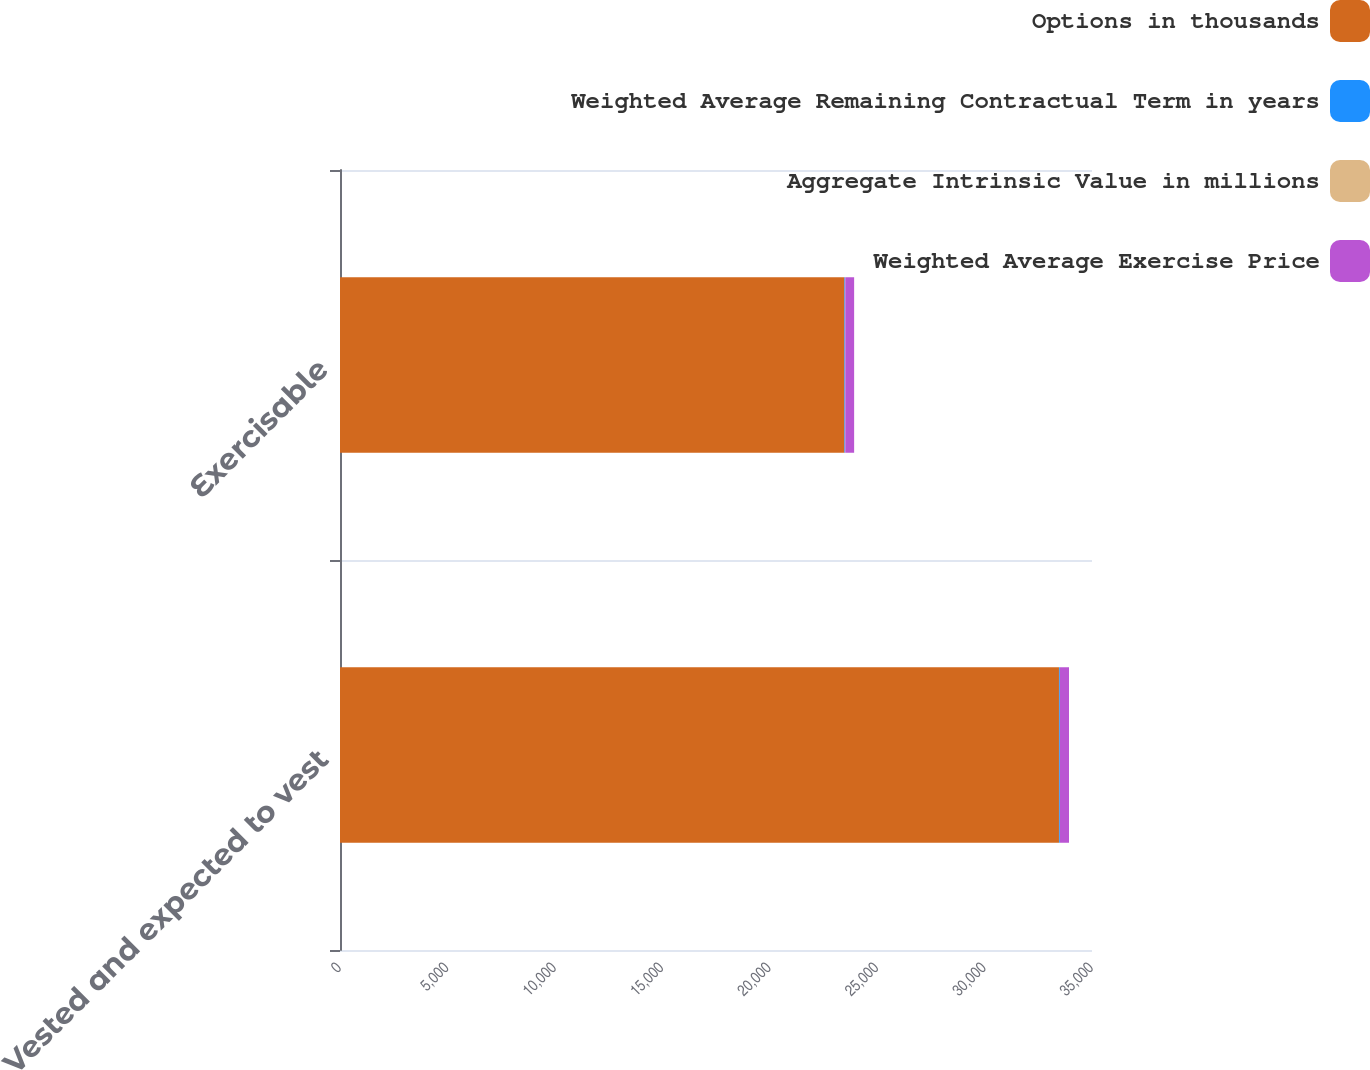Convert chart. <chart><loc_0><loc_0><loc_500><loc_500><stacked_bar_chart><ecel><fcel>Vested and expected to vest<fcel>Exercisable<nl><fcel>Options in thousands<fcel>33463<fcel>23479<nl><fcel>Weighted Average Remaining Contractual Term in years<fcel>39.82<fcel>33.99<nl><fcel>Aggregate Intrinsic Value in millions<fcel>6<fcel>5.1<nl><fcel>Weighted Average Exercise Price<fcel>421<fcel>411<nl></chart> 